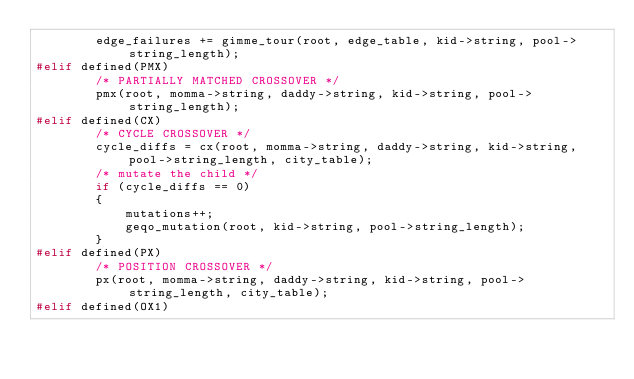Convert code to text. <code><loc_0><loc_0><loc_500><loc_500><_C++_>		edge_failures += gimme_tour(root, edge_table, kid->string, pool->string_length);
#elif defined(PMX)
		/* PARTIALLY MATCHED CROSSOVER */
		pmx(root, momma->string, daddy->string, kid->string, pool->string_length);
#elif defined(CX)
		/* CYCLE CROSSOVER */
		cycle_diffs = cx(root, momma->string, daddy->string, kid->string, pool->string_length, city_table);
		/* mutate the child */
		if (cycle_diffs == 0)
		{
			mutations++;
			geqo_mutation(root, kid->string, pool->string_length);
		}
#elif defined(PX)
		/* POSITION CROSSOVER */
		px(root, momma->string, daddy->string, kid->string, pool->string_length, city_table);
#elif defined(OX1)</code> 